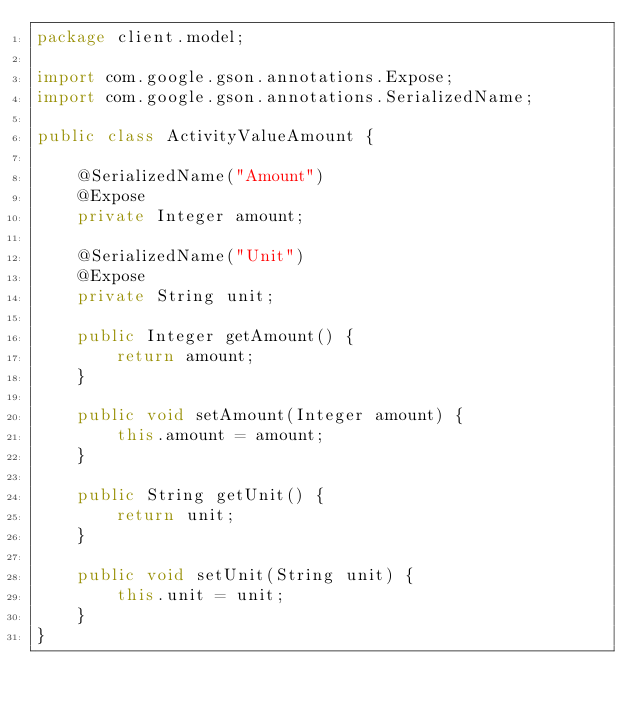Convert code to text. <code><loc_0><loc_0><loc_500><loc_500><_Java_>package client.model;

import com.google.gson.annotations.Expose;
import com.google.gson.annotations.SerializedName;

public class ActivityValueAmount {

    @SerializedName("Amount")
    @Expose
    private Integer amount;

    @SerializedName("Unit")
    @Expose
    private String unit;

    public Integer getAmount() {
        return amount;
    }

    public void setAmount(Integer amount) {
        this.amount = amount;
    }

    public String getUnit() {
        return unit;
    }

    public void setUnit(String unit) {
        this.unit = unit;
    }
}
</code> 